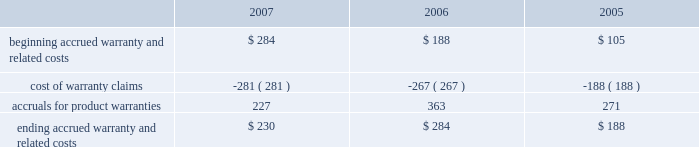Notes to consolidated financial statements ( continued ) note 8 2014commitments and contingencies ( continued ) the table reconciles changes in the company 2019s accrued warranties and related costs ( in millions ) : .
The company generally does not indemnify end-users of its operating system and application software against legal claims that the software infringes third-party intellectual property rights .
Other agreements entered into by the company sometimes include indemnification provisions under which the company could be subject to costs and/or damages in the event of an infringement claim against the company or an indemnified third-party .
However , the company has not been required to make any significant payments resulting from such an infringement claim asserted against itself or an indemnified third-party and , in the opinion of management , does not have a potential liability related to unresolved infringement claims subject to indemnification that would have a material adverse effect on its financial condition or operating results .
Therefore , the company did not record a liability for infringement costs as of either september 29 , 2007 or september 30 , 2006 .
Concentrations in the available sources of supply of materials and product certain key components including , but not limited to , microprocessors , enclosures , certain lcds , certain optical drives , and application-specific integrated circuits ( 2018 2018asics 2019 2019 ) are currently obtained by the company from single or limited sources which subjects the company to supply and pricing risks .
Many of these and other key components that are available from multiple sources including , but not limited to , nand flash memory , dram memory , and certain lcds , are at times subject to industry-wide shortages and significant commodity pricing fluctuations .
In addition , the company has entered into certain agreements for the supply of critical components at favorable pricing , and there is no guarantee that the company will be able to extend or renew these agreements when they expire .
Therefore , the company remains subject to significant risks of supply shortages and/or price increases that can adversely affect gross margins and operating margins .
In addition , the company uses some components that are not common to the rest of the global personal computer , consumer electronics and mobile communication industries , and new products introduced by the company often utilize custom components obtained from only one source until the company has evaluated whether there is a need for and subsequently qualifies additional suppliers .
If the supply of a key single-sourced component to the company were to be delayed or curtailed , or in the event a key manufacturing vendor delays shipments of completed products to the company , the company 2019s ability to ship related products in desired quantities and in a timely manner could be adversely affected .
The company 2019s business and financial performance could also be adversely affected depending on the time required to obtain sufficient quantities from the original source , or to identify and obtain sufficient quantities from an alternative source .
Continued availability of these components may be affected if producers were to decide to concentrate on the production of common components instead of components customized to meet the company 2019s requirements .
Finally , significant portions of the company 2019s cpus , ipods , iphones , logic boards , and other assembled products are now manufactured by outsourcing partners , primarily in various parts of asia .
A significant concentration of this outsourced manufacturing is currently performed by only a few of the company 2019s outsourcing partners , often in single locations .
Certain of these outsourcing partners are the sole-sourced supplier of components and manufacturing outsourcing for many of the company 2019s key products , including but not limited to , assembly .
What was the average accruals for product warranties , in millions? 
Computations: table_average(accruals for product warranties, none)
Answer: 287.0. 